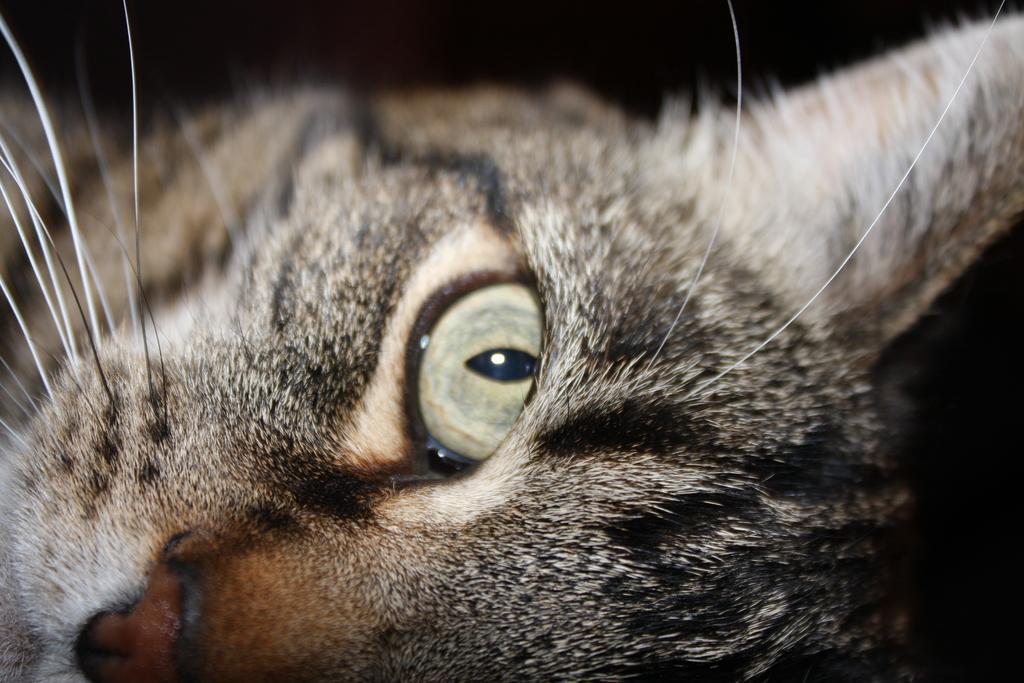In one or two sentences, can you explain what this image depicts? In this picture we can see a cat and in the background it is dark. 